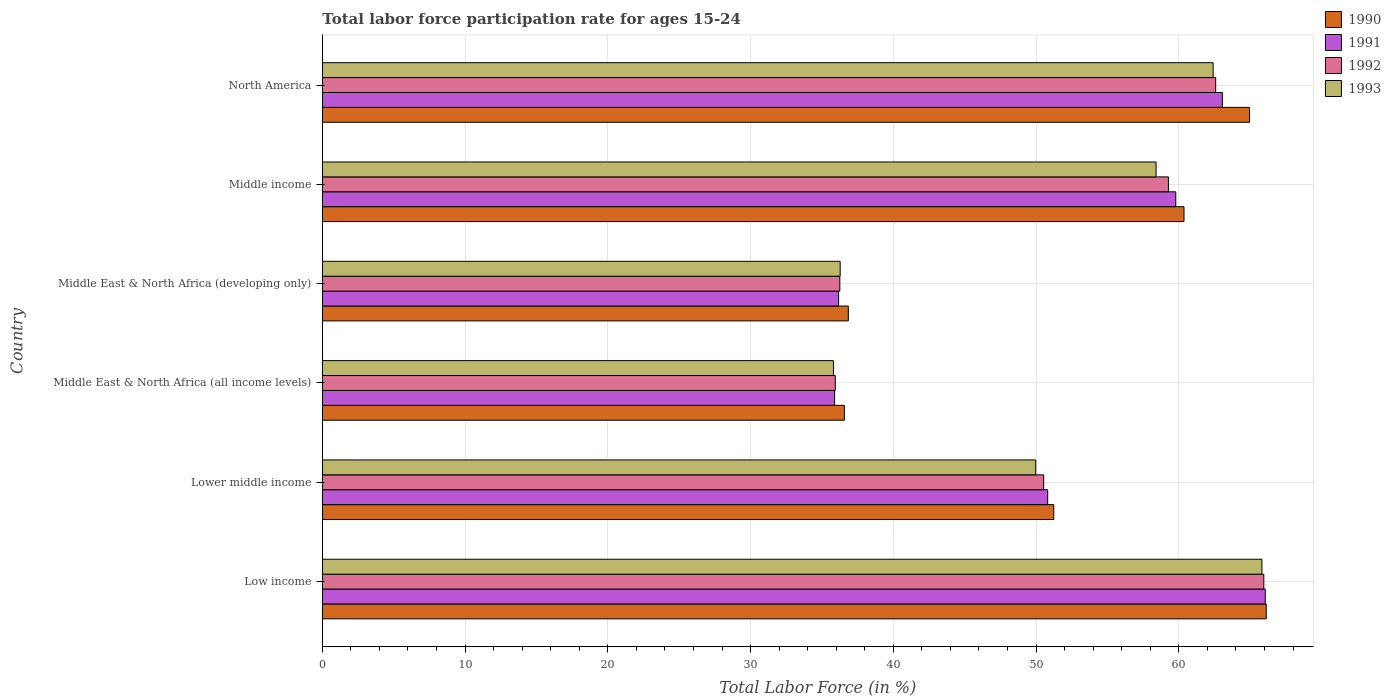How many groups of bars are there?
Provide a succinct answer. 6. Are the number of bars on each tick of the Y-axis equal?
Provide a short and direct response. Yes. What is the label of the 1st group of bars from the top?
Offer a very short reply. North America. What is the labor force participation rate in 1993 in Middle East & North Africa (developing only)?
Your answer should be compact. 36.28. Across all countries, what is the maximum labor force participation rate in 1991?
Provide a succinct answer. 66.06. Across all countries, what is the minimum labor force participation rate in 1990?
Keep it short and to the point. 36.57. In which country was the labor force participation rate in 1991 maximum?
Provide a short and direct response. Low income. In which country was the labor force participation rate in 1992 minimum?
Keep it short and to the point. Middle East & North Africa (all income levels). What is the total labor force participation rate in 1991 in the graph?
Offer a very short reply. 311.77. What is the difference between the labor force participation rate in 1993 in Low income and that in North America?
Ensure brevity in your answer.  3.42. What is the difference between the labor force participation rate in 1990 in Middle East & North Africa (all income levels) and the labor force participation rate in 1992 in Low income?
Provide a succinct answer. -29.39. What is the average labor force participation rate in 1993 per country?
Ensure brevity in your answer.  51.45. What is the difference between the labor force participation rate in 1990 and labor force participation rate in 1991 in Middle East & North Africa (all income levels)?
Your answer should be compact. 0.68. In how many countries, is the labor force participation rate in 1992 greater than 4 %?
Offer a very short reply. 6. What is the ratio of the labor force participation rate in 1990 in Low income to that in Middle East & North Africa (developing only)?
Your response must be concise. 1.79. Is the difference between the labor force participation rate in 1990 in Middle East & North Africa (developing only) and Middle income greater than the difference between the labor force participation rate in 1991 in Middle East & North Africa (developing only) and Middle income?
Your response must be concise. Yes. What is the difference between the highest and the second highest labor force participation rate in 1990?
Give a very brief answer. 1.17. What is the difference between the highest and the lowest labor force participation rate in 1992?
Make the answer very short. 30.02. Is the sum of the labor force participation rate in 1992 in Middle East & North Africa (all income levels) and North America greater than the maximum labor force participation rate in 1990 across all countries?
Keep it short and to the point. Yes. What does the 2nd bar from the top in Middle East & North Africa (developing only) represents?
Provide a succinct answer. 1992. What does the 4th bar from the bottom in Low income represents?
Give a very brief answer. 1993. What is the difference between two consecutive major ticks on the X-axis?
Provide a short and direct response. 10. What is the title of the graph?
Provide a short and direct response. Total labor force participation rate for ages 15-24. Does "2011" appear as one of the legend labels in the graph?
Make the answer very short. No. What is the Total Labor Force (in %) in 1990 in Low income?
Offer a terse response. 66.13. What is the Total Labor Force (in %) in 1991 in Low income?
Your answer should be compact. 66.06. What is the Total Labor Force (in %) in 1992 in Low income?
Ensure brevity in your answer.  65.96. What is the Total Labor Force (in %) in 1993 in Low income?
Your response must be concise. 65.82. What is the Total Labor Force (in %) of 1990 in Lower middle income?
Your answer should be very brief. 51.24. What is the Total Labor Force (in %) of 1991 in Lower middle income?
Your answer should be very brief. 50.82. What is the Total Labor Force (in %) in 1992 in Lower middle income?
Offer a very short reply. 50.54. What is the Total Labor Force (in %) of 1993 in Lower middle income?
Your answer should be compact. 49.98. What is the Total Labor Force (in %) in 1990 in Middle East & North Africa (all income levels)?
Make the answer very short. 36.57. What is the Total Labor Force (in %) of 1991 in Middle East & North Africa (all income levels)?
Ensure brevity in your answer.  35.89. What is the Total Labor Force (in %) of 1992 in Middle East & North Africa (all income levels)?
Your answer should be compact. 35.93. What is the Total Labor Force (in %) of 1993 in Middle East & North Africa (all income levels)?
Give a very brief answer. 35.81. What is the Total Labor Force (in %) in 1990 in Middle East & North Africa (developing only)?
Provide a succinct answer. 36.85. What is the Total Labor Force (in %) in 1991 in Middle East & North Africa (developing only)?
Provide a short and direct response. 36.17. What is the Total Labor Force (in %) in 1992 in Middle East & North Africa (developing only)?
Your answer should be very brief. 36.25. What is the Total Labor Force (in %) in 1993 in Middle East & North Africa (developing only)?
Ensure brevity in your answer.  36.28. What is the Total Labor Force (in %) in 1990 in Middle income?
Give a very brief answer. 60.36. What is the Total Labor Force (in %) in 1991 in Middle income?
Offer a terse response. 59.79. What is the Total Labor Force (in %) in 1992 in Middle income?
Give a very brief answer. 59.27. What is the Total Labor Force (in %) of 1993 in Middle income?
Provide a succinct answer. 58.41. What is the Total Labor Force (in %) of 1990 in North America?
Your answer should be compact. 64.95. What is the Total Labor Force (in %) of 1991 in North America?
Your response must be concise. 63.05. What is the Total Labor Force (in %) of 1992 in North America?
Provide a succinct answer. 62.58. What is the Total Labor Force (in %) of 1993 in North America?
Offer a terse response. 62.41. Across all countries, what is the maximum Total Labor Force (in %) of 1990?
Provide a succinct answer. 66.13. Across all countries, what is the maximum Total Labor Force (in %) of 1991?
Offer a terse response. 66.06. Across all countries, what is the maximum Total Labor Force (in %) in 1992?
Offer a very short reply. 65.96. Across all countries, what is the maximum Total Labor Force (in %) of 1993?
Ensure brevity in your answer.  65.82. Across all countries, what is the minimum Total Labor Force (in %) in 1990?
Provide a short and direct response. 36.57. Across all countries, what is the minimum Total Labor Force (in %) in 1991?
Your answer should be compact. 35.89. Across all countries, what is the minimum Total Labor Force (in %) of 1992?
Offer a terse response. 35.93. Across all countries, what is the minimum Total Labor Force (in %) of 1993?
Provide a succinct answer. 35.81. What is the total Total Labor Force (in %) of 1990 in the graph?
Give a very brief answer. 316.1. What is the total Total Labor Force (in %) in 1991 in the graph?
Give a very brief answer. 311.77. What is the total Total Labor Force (in %) of 1992 in the graph?
Your answer should be compact. 310.54. What is the total Total Labor Force (in %) in 1993 in the graph?
Offer a very short reply. 308.7. What is the difference between the Total Labor Force (in %) in 1990 in Low income and that in Lower middle income?
Your response must be concise. 14.88. What is the difference between the Total Labor Force (in %) of 1991 in Low income and that in Lower middle income?
Give a very brief answer. 15.24. What is the difference between the Total Labor Force (in %) in 1992 in Low income and that in Lower middle income?
Make the answer very short. 15.42. What is the difference between the Total Labor Force (in %) of 1993 in Low income and that in Lower middle income?
Keep it short and to the point. 15.85. What is the difference between the Total Labor Force (in %) in 1990 in Low income and that in Middle East & North Africa (all income levels)?
Your response must be concise. 29.55. What is the difference between the Total Labor Force (in %) of 1991 in Low income and that in Middle East & North Africa (all income levels)?
Offer a terse response. 30.17. What is the difference between the Total Labor Force (in %) in 1992 in Low income and that in Middle East & North Africa (all income levels)?
Keep it short and to the point. 30.02. What is the difference between the Total Labor Force (in %) of 1993 in Low income and that in Middle East & North Africa (all income levels)?
Your response must be concise. 30.02. What is the difference between the Total Labor Force (in %) in 1990 in Low income and that in Middle East & North Africa (developing only)?
Provide a succinct answer. 29.28. What is the difference between the Total Labor Force (in %) of 1991 in Low income and that in Middle East & North Africa (developing only)?
Provide a short and direct response. 29.89. What is the difference between the Total Labor Force (in %) in 1992 in Low income and that in Middle East & North Africa (developing only)?
Offer a terse response. 29.7. What is the difference between the Total Labor Force (in %) of 1993 in Low income and that in Middle East & North Africa (developing only)?
Give a very brief answer. 29.55. What is the difference between the Total Labor Force (in %) of 1990 in Low income and that in Middle income?
Ensure brevity in your answer.  5.76. What is the difference between the Total Labor Force (in %) of 1991 in Low income and that in Middle income?
Your answer should be compact. 6.27. What is the difference between the Total Labor Force (in %) of 1992 in Low income and that in Middle income?
Provide a short and direct response. 6.68. What is the difference between the Total Labor Force (in %) of 1993 in Low income and that in Middle income?
Offer a very short reply. 7.41. What is the difference between the Total Labor Force (in %) of 1990 in Low income and that in North America?
Your answer should be compact. 1.17. What is the difference between the Total Labor Force (in %) in 1991 in Low income and that in North America?
Ensure brevity in your answer.  3. What is the difference between the Total Labor Force (in %) in 1992 in Low income and that in North America?
Provide a short and direct response. 3.37. What is the difference between the Total Labor Force (in %) in 1993 in Low income and that in North America?
Provide a short and direct response. 3.42. What is the difference between the Total Labor Force (in %) in 1990 in Lower middle income and that in Middle East & North Africa (all income levels)?
Provide a succinct answer. 14.67. What is the difference between the Total Labor Force (in %) in 1991 in Lower middle income and that in Middle East & North Africa (all income levels)?
Your answer should be very brief. 14.93. What is the difference between the Total Labor Force (in %) in 1992 in Lower middle income and that in Middle East & North Africa (all income levels)?
Provide a succinct answer. 14.6. What is the difference between the Total Labor Force (in %) in 1993 in Lower middle income and that in Middle East & North Africa (all income levels)?
Provide a short and direct response. 14.17. What is the difference between the Total Labor Force (in %) in 1990 in Lower middle income and that in Middle East & North Africa (developing only)?
Offer a terse response. 14.39. What is the difference between the Total Labor Force (in %) of 1991 in Lower middle income and that in Middle East & North Africa (developing only)?
Offer a terse response. 14.65. What is the difference between the Total Labor Force (in %) of 1992 in Lower middle income and that in Middle East & North Africa (developing only)?
Provide a short and direct response. 14.28. What is the difference between the Total Labor Force (in %) in 1993 in Lower middle income and that in Middle East & North Africa (developing only)?
Your answer should be very brief. 13.7. What is the difference between the Total Labor Force (in %) of 1990 in Lower middle income and that in Middle income?
Ensure brevity in your answer.  -9.12. What is the difference between the Total Labor Force (in %) in 1991 in Lower middle income and that in Middle income?
Ensure brevity in your answer.  -8.97. What is the difference between the Total Labor Force (in %) of 1992 in Lower middle income and that in Middle income?
Ensure brevity in your answer.  -8.74. What is the difference between the Total Labor Force (in %) in 1993 in Lower middle income and that in Middle income?
Provide a succinct answer. -8.43. What is the difference between the Total Labor Force (in %) of 1990 in Lower middle income and that in North America?
Your answer should be very brief. -13.71. What is the difference between the Total Labor Force (in %) in 1991 in Lower middle income and that in North America?
Your response must be concise. -12.24. What is the difference between the Total Labor Force (in %) in 1992 in Lower middle income and that in North America?
Give a very brief answer. -12.05. What is the difference between the Total Labor Force (in %) of 1993 in Lower middle income and that in North America?
Your answer should be very brief. -12.43. What is the difference between the Total Labor Force (in %) in 1990 in Middle East & North Africa (all income levels) and that in Middle East & North Africa (developing only)?
Give a very brief answer. -0.28. What is the difference between the Total Labor Force (in %) in 1991 in Middle East & North Africa (all income levels) and that in Middle East & North Africa (developing only)?
Offer a very short reply. -0.28. What is the difference between the Total Labor Force (in %) in 1992 in Middle East & North Africa (all income levels) and that in Middle East & North Africa (developing only)?
Provide a succinct answer. -0.32. What is the difference between the Total Labor Force (in %) in 1993 in Middle East & North Africa (all income levels) and that in Middle East & North Africa (developing only)?
Provide a short and direct response. -0.47. What is the difference between the Total Labor Force (in %) of 1990 in Middle East & North Africa (all income levels) and that in Middle income?
Keep it short and to the point. -23.79. What is the difference between the Total Labor Force (in %) in 1991 in Middle East & North Africa (all income levels) and that in Middle income?
Ensure brevity in your answer.  -23.9. What is the difference between the Total Labor Force (in %) of 1992 in Middle East & North Africa (all income levels) and that in Middle income?
Offer a very short reply. -23.34. What is the difference between the Total Labor Force (in %) in 1993 in Middle East & North Africa (all income levels) and that in Middle income?
Offer a very short reply. -22.6. What is the difference between the Total Labor Force (in %) in 1990 in Middle East & North Africa (all income levels) and that in North America?
Offer a very short reply. -28.38. What is the difference between the Total Labor Force (in %) of 1991 in Middle East & North Africa (all income levels) and that in North America?
Give a very brief answer. -27.16. What is the difference between the Total Labor Force (in %) in 1992 in Middle East & North Africa (all income levels) and that in North America?
Provide a succinct answer. -26.65. What is the difference between the Total Labor Force (in %) in 1993 in Middle East & North Africa (all income levels) and that in North America?
Provide a short and direct response. -26.6. What is the difference between the Total Labor Force (in %) in 1990 in Middle East & North Africa (developing only) and that in Middle income?
Your response must be concise. -23.52. What is the difference between the Total Labor Force (in %) of 1991 in Middle East & North Africa (developing only) and that in Middle income?
Ensure brevity in your answer.  -23.62. What is the difference between the Total Labor Force (in %) in 1992 in Middle East & North Africa (developing only) and that in Middle income?
Keep it short and to the point. -23.02. What is the difference between the Total Labor Force (in %) in 1993 in Middle East & North Africa (developing only) and that in Middle income?
Your answer should be compact. -22.13. What is the difference between the Total Labor Force (in %) in 1990 in Middle East & North Africa (developing only) and that in North America?
Your answer should be very brief. -28.11. What is the difference between the Total Labor Force (in %) of 1991 in Middle East & North Africa (developing only) and that in North America?
Offer a very short reply. -26.88. What is the difference between the Total Labor Force (in %) of 1992 in Middle East & North Africa (developing only) and that in North America?
Offer a terse response. -26.33. What is the difference between the Total Labor Force (in %) in 1993 in Middle East & North Africa (developing only) and that in North America?
Provide a short and direct response. -26.13. What is the difference between the Total Labor Force (in %) in 1990 in Middle income and that in North America?
Your answer should be compact. -4.59. What is the difference between the Total Labor Force (in %) in 1991 in Middle income and that in North America?
Make the answer very short. -3.26. What is the difference between the Total Labor Force (in %) of 1992 in Middle income and that in North America?
Your response must be concise. -3.31. What is the difference between the Total Labor Force (in %) of 1993 in Middle income and that in North America?
Make the answer very short. -4. What is the difference between the Total Labor Force (in %) of 1990 in Low income and the Total Labor Force (in %) of 1991 in Lower middle income?
Make the answer very short. 15.31. What is the difference between the Total Labor Force (in %) in 1990 in Low income and the Total Labor Force (in %) in 1992 in Lower middle income?
Provide a succinct answer. 15.59. What is the difference between the Total Labor Force (in %) in 1990 in Low income and the Total Labor Force (in %) in 1993 in Lower middle income?
Your response must be concise. 16.15. What is the difference between the Total Labor Force (in %) of 1991 in Low income and the Total Labor Force (in %) of 1992 in Lower middle income?
Give a very brief answer. 15.52. What is the difference between the Total Labor Force (in %) in 1991 in Low income and the Total Labor Force (in %) in 1993 in Lower middle income?
Your answer should be compact. 16.08. What is the difference between the Total Labor Force (in %) in 1992 in Low income and the Total Labor Force (in %) in 1993 in Lower middle income?
Ensure brevity in your answer.  15.98. What is the difference between the Total Labor Force (in %) of 1990 in Low income and the Total Labor Force (in %) of 1991 in Middle East & North Africa (all income levels)?
Make the answer very short. 30.24. What is the difference between the Total Labor Force (in %) of 1990 in Low income and the Total Labor Force (in %) of 1992 in Middle East & North Africa (all income levels)?
Provide a short and direct response. 30.19. What is the difference between the Total Labor Force (in %) of 1990 in Low income and the Total Labor Force (in %) of 1993 in Middle East & North Africa (all income levels)?
Your answer should be compact. 30.32. What is the difference between the Total Labor Force (in %) of 1991 in Low income and the Total Labor Force (in %) of 1992 in Middle East & North Africa (all income levels)?
Offer a very short reply. 30.12. What is the difference between the Total Labor Force (in %) of 1991 in Low income and the Total Labor Force (in %) of 1993 in Middle East & North Africa (all income levels)?
Your response must be concise. 30.25. What is the difference between the Total Labor Force (in %) of 1992 in Low income and the Total Labor Force (in %) of 1993 in Middle East & North Africa (all income levels)?
Your response must be concise. 30.15. What is the difference between the Total Labor Force (in %) of 1990 in Low income and the Total Labor Force (in %) of 1991 in Middle East & North Africa (developing only)?
Provide a succinct answer. 29.96. What is the difference between the Total Labor Force (in %) of 1990 in Low income and the Total Labor Force (in %) of 1992 in Middle East & North Africa (developing only)?
Your response must be concise. 29.87. What is the difference between the Total Labor Force (in %) in 1990 in Low income and the Total Labor Force (in %) in 1993 in Middle East & North Africa (developing only)?
Offer a terse response. 29.85. What is the difference between the Total Labor Force (in %) of 1991 in Low income and the Total Labor Force (in %) of 1992 in Middle East & North Africa (developing only)?
Provide a short and direct response. 29.8. What is the difference between the Total Labor Force (in %) in 1991 in Low income and the Total Labor Force (in %) in 1993 in Middle East & North Africa (developing only)?
Provide a short and direct response. 29.78. What is the difference between the Total Labor Force (in %) of 1992 in Low income and the Total Labor Force (in %) of 1993 in Middle East & North Africa (developing only)?
Provide a succinct answer. 29.68. What is the difference between the Total Labor Force (in %) in 1990 in Low income and the Total Labor Force (in %) in 1991 in Middle income?
Keep it short and to the point. 6.34. What is the difference between the Total Labor Force (in %) of 1990 in Low income and the Total Labor Force (in %) of 1992 in Middle income?
Ensure brevity in your answer.  6.85. What is the difference between the Total Labor Force (in %) of 1990 in Low income and the Total Labor Force (in %) of 1993 in Middle income?
Your response must be concise. 7.72. What is the difference between the Total Labor Force (in %) of 1991 in Low income and the Total Labor Force (in %) of 1992 in Middle income?
Provide a succinct answer. 6.78. What is the difference between the Total Labor Force (in %) of 1991 in Low income and the Total Labor Force (in %) of 1993 in Middle income?
Keep it short and to the point. 7.65. What is the difference between the Total Labor Force (in %) in 1992 in Low income and the Total Labor Force (in %) in 1993 in Middle income?
Your answer should be compact. 7.55. What is the difference between the Total Labor Force (in %) of 1990 in Low income and the Total Labor Force (in %) of 1991 in North America?
Keep it short and to the point. 3.07. What is the difference between the Total Labor Force (in %) of 1990 in Low income and the Total Labor Force (in %) of 1992 in North America?
Your answer should be compact. 3.54. What is the difference between the Total Labor Force (in %) in 1990 in Low income and the Total Labor Force (in %) in 1993 in North America?
Keep it short and to the point. 3.72. What is the difference between the Total Labor Force (in %) of 1991 in Low income and the Total Labor Force (in %) of 1992 in North America?
Make the answer very short. 3.47. What is the difference between the Total Labor Force (in %) of 1991 in Low income and the Total Labor Force (in %) of 1993 in North America?
Give a very brief answer. 3.65. What is the difference between the Total Labor Force (in %) of 1992 in Low income and the Total Labor Force (in %) of 1993 in North America?
Give a very brief answer. 3.55. What is the difference between the Total Labor Force (in %) in 1990 in Lower middle income and the Total Labor Force (in %) in 1991 in Middle East & North Africa (all income levels)?
Give a very brief answer. 15.35. What is the difference between the Total Labor Force (in %) in 1990 in Lower middle income and the Total Labor Force (in %) in 1992 in Middle East & North Africa (all income levels)?
Make the answer very short. 15.31. What is the difference between the Total Labor Force (in %) of 1990 in Lower middle income and the Total Labor Force (in %) of 1993 in Middle East & North Africa (all income levels)?
Keep it short and to the point. 15.44. What is the difference between the Total Labor Force (in %) in 1991 in Lower middle income and the Total Labor Force (in %) in 1992 in Middle East & North Africa (all income levels)?
Your response must be concise. 14.88. What is the difference between the Total Labor Force (in %) in 1991 in Lower middle income and the Total Labor Force (in %) in 1993 in Middle East & North Africa (all income levels)?
Your answer should be compact. 15.01. What is the difference between the Total Labor Force (in %) in 1992 in Lower middle income and the Total Labor Force (in %) in 1993 in Middle East & North Africa (all income levels)?
Offer a very short reply. 14.73. What is the difference between the Total Labor Force (in %) of 1990 in Lower middle income and the Total Labor Force (in %) of 1991 in Middle East & North Africa (developing only)?
Provide a short and direct response. 15.07. What is the difference between the Total Labor Force (in %) in 1990 in Lower middle income and the Total Labor Force (in %) in 1992 in Middle East & North Africa (developing only)?
Your answer should be very brief. 14.99. What is the difference between the Total Labor Force (in %) of 1990 in Lower middle income and the Total Labor Force (in %) of 1993 in Middle East & North Africa (developing only)?
Your response must be concise. 14.96. What is the difference between the Total Labor Force (in %) of 1991 in Lower middle income and the Total Labor Force (in %) of 1992 in Middle East & North Africa (developing only)?
Your response must be concise. 14.56. What is the difference between the Total Labor Force (in %) of 1991 in Lower middle income and the Total Labor Force (in %) of 1993 in Middle East & North Africa (developing only)?
Provide a short and direct response. 14.54. What is the difference between the Total Labor Force (in %) of 1992 in Lower middle income and the Total Labor Force (in %) of 1993 in Middle East & North Africa (developing only)?
Your answer should be compact. 14.26. What is the difference between the Total Labor Force (in %) of 1990 in Lower middle income and the Total Labor Force (in %) of 1991 in Middle income?
Provide a succinct answer. -8.55. What is the difference between the Total Labor Force (in %) in 1990 in Lower middle income and the Total Labor Force (in %) in 1992 in Middle income?
Offer a very short reply. -8.03. What is the difference between the Total Labor Force (in %) in 1990 in Lower middle income and the Total Labor Force (in %) in 1993 in Middle income?
Your response must be concise. -7.17. What is the difference between the Total Labor Force (in %) of 1991 in Lower middle income and the Total Labor Force (in %) of 1992 in Middle income?
Ensure brevity in your answer.  -8.46. What is the difference between the Total Labor Force (in %) of 1991 in Lower middle income and the Total Labor Force (in %) of 1993 in Middle income?
Your answer should be very brief. -7.59. What is the difference between the Total Labor Force (in %) of 1992 in Lower middle income and the Total Labor Force (in %) of 1993 in Middle income?
Give a very brief answer. -7.87. What is the difference between the Total Labor Force (in %) in 1990 in Lower middle income and the Total Labor Force (in %) in 1991 in North America?
Provide a short and direct response. -11.81. What is the difference between the Total Labor Force (in %) in 1990 in Lower middle income and the Total Labor Force (in %) in 1992 in North America?
Make the answer very short. -11.34. What is the difference between the Total Labor Force (in %) of 1990 in Lower middle income and the Total Labor Force (in %) of 1993 in North America?
Ensure brevity in your answer.  -11.16. What is the difference between the Total Labor Force (in %) in 1991 in Lower middle income and the Total Labor Force (in %) in 1992 in North America?
Give a very brief answer. -11.77. What is the difference between the Total Labor Force (in %) of 1991 in Lower middle income and the Total Labor Force (in %) of 1993 in North America?
Give a very brief answer. -11.59. What is the difference between the Total Labor Force (in %) in 1992 in Lower middle income and the Total Labor Force (in %) in 1993 in North America?
Your response must be concise. -11.87. What is the difference between the Total Labor Force (in %) in 1990 in Middle East & North Africa (all income levels) and the Total Labor Force (in %) in 1991 in Middle East & North Africa (developing only)?
Ensure brevity in your answer.  0.4. What is the difference between the Total Labor Force (in %) of 1990 in Middle East & North Africa (all income levels) and the Total Labor Force (in %) of 1992 in Middle East & North Africa (developing only)?
Your answer should be compact. 0.32. What is the difference between the Total Labor Force (in %) of 1990 in Middle East & North Africa (all income levels) and the Total Labor Force (in %) of 1993 in Middle East & North Africa (developing only)?
Provide a succinct answer. 0.29. What is the difference between the Total Labor Force (in %) of 1991 in Middle East & North Africa (all income levels) and the Total Labor Force (in %) of 1992 in Middle East & North Africa (developing only)?
Offer a terse response. -0.36. What is the difference between the Total Labor Force (in %) in 1991 in Middle East & North Africa (all income levels) and the Total Labor Force (in %) in 1993 in Middle East & North Africa (developing only)?
Ensure brevity in your answer.  -0.39. What is the difference between the Total Labor Force (in %) of 1992 in Middle East & North Africa (all income levels) and the Total Labor Force (in %) of 1993 in Middle East & North Africa (developing only)?
Keep it short and to the point. -0.34. What is the difference between the Total Labor Force (in %) in 1990 in Middle East & North Africa (all income levels) and the Total Labor Force (in %) in 1991 in Middle income?
Provide a short and direct response. -23.22. What is the difference between the Total Labor Force (in %) of 1990 in Middle East & North Africa (all income levels) and the Total Labor Force (in %) of 1992 in Middle income?
Give a very brief answer. -22.7. What is the difference between the Total Labor Force (in %) in 1990 in Middle East & North Africa (all income levels) and the Total Labor Force (in %) in 1993 in Middle income?
Ensure brevity in your answer.  -21.84. What is the difference between the Total Labor Force (in %) of 1991 in Middle East & North Africa (all income levels) and the Total Labor Force (in %) of 1992 in Middle income?
Ensure brevity in your answer.  -23.39. What is the difference between the Total Labor Force (in %) in 1991 in Middle East & North Africa (all income levels) and the Total Labor Force (in %) in 1993 in Middle income?
Give a very brief answer. -22.52. What is the difference between the Total Labor Force (in %) of 1992 in Middle East & North Africa (all income levels) and the Total Labor Force (in %) of 1993 in Middle income?
Provide a short and direct response. -22.47. What is the difference between the Total Labor Force (in %) in 1990 in Middle East & North Africa (all income levels) and the Total Labor Force (in %) in 1991 in North America?
Keep it short and to the point. -26.48. What is the difference between the Total Labor Force (in %) in 1990 in Middle East & North Africa (all income levels) and the Total Labor Force (in %) in 1992 in North America?
Ensure brevity in your answer.  -26.01. What is the difference between the Total Labor Force (in %) of 1990 in Middle East & North Africa (all income levels) and the Total Labor Force (in %) of 1993 in North America?
Your response must be concise. -25.84. What is the difference between the Total Labor Force (in %) of 1991 in Middle East & North Africa (all income levels) and the Total Labor Force (in %) of 1992 in North America?
Your response must be concise. -26.69. What is the difference between the Total Labor Force (in %) in 1991 in Middle East & North Africa (all income levels) and the Total Labor Force (in %) in 1993 in North America?
Give a very brief answer. -26.52. What is the difference between the Total Labor Force (in %) of 1992 in Middle East & North Africa (all income levels) and the Total Labor Force (in %) of 1993 in North America?
Offer a very short reply. -26.47. What is the difference between the Total Labor Force (in %) of 1990 in Middle East & North Africa (developing only) and the Total Labor Force (in %) of 1991 in Middle income?
Offer a terse response. -22.94. What is the difference between the Total Labor Force (in %) of 1990 in Middle East & North Africa (developing only) and the Total Labor Force (in %) of 1992 in Middle income?
Offer a very short reply. -22.43. What is the difference between the Total Labor Force (in %) of 1990 in Middle East & North Africa (developing only) and the Total Labor Force (in %) of 1993 in Middle income?
Make the answer very short. -21.56. What is the difference between the Total Labor Force (in %) of 1991 in Middle East & North Africa (developing only) and the Total Labor Force (in %) of 1992 in Middle income?
Ensure brevity in your answer.  -23.11. What is the difference between the Total Labor Force (in %) in 1991 in Middle East & North Africa (developing only) and the Total Labor Force (in %) in 1993 in Middle income?
Provide a succinct answer. -22.24. What is the difference between the Total Labor Force (in %) in 1992 in Middle East & North Africa (developing only) and the Total Labor Force (in %) in 1993 in Middle income?
Give a very brief answer. -22.16. What is the difference between the Total Labor Force (in %) of 1990 in Middle East & North Africa (developing only) and the Total Labor Force (in %) of 1991 in North America?
Give a very brief answer. -26.2. What is the difference between the Total Labor Force (in %) of 1990 in Middle East & North Africa (developing only) and the Total Labor Force (in %) of 1992 in North America?
Your answer should be compact. -25.74. What is the difference between the Total Labor Force (in %) in 1990 in Middle East & North Africa (developing only) and the Total Labor Force (in %) in 1993 in North America?
Offer a very short reply. -25.56. What is the difference between the Total Labor Force (in %) in 1991 in Middle East & North Africa (developing only) and the Total Labor Force (in %) in 1992 in North America?
Provide a succinct answer. -26.42. What is the difference between the Total Labor Force (in %) of 1991 in Middle East & North Africa (developing only) and the Total Labor Force (in %) of 1993 in North America?
Your response must be concise. -26.24. What is the difference between the Total Labor Force (in %) of 1992 in Middle East & North Africa (developing only) and the Total Labor Force (in %) of 1993 in North America?
Your answer should be compact. -26.15. What is the difference between the Total Labor Force (in %) in 1990 in Middle income and the Total Labor Force (in %) in 1991 in North America?
Your response must be concise. -2.69. What is the difference between the Total Labor Force (in %) in 1990 in Middle income and the Total Labor Force (in %) in 1992 in North America?
Ensure brevity in your answer.  -2.22. What is the difference between the Total Labor Force (in %) in 1990 in Middle income and the Total Labor Force (in %) in 1993 in North America?
Provide a succinct answer. -2.04. What is the difference between the Total Labor Force (in %) in 1991 in Middle income and the Total Labor Force (in %) in 1992 in North America?
Give a very brief answer. -2.8. What is the difference between the Total Labor Force (in %) of 1991 in Middle income and the Total Labor Force (in %) of 1993 in North America?
Your answer should be compact. -2.62. What is the difference between the Total Labor Force (in %) of 1992 in Middle income and the Total Labor Force (in %) of 1993 in North America?
Provide a short and direct response. -3.13. What is the average Total Labor Force (in %) in 1990 per country?
Your response must be concise. 52.68. What is the average Total Labor Force (in %) of 1991 per country?
Give a very brief answer. 51.96. What is the average Total Labor Force (in %) of 1992 per country?
Provide a succinct answer. 51.76. What is the average Total Labor Force (in %) in 1993 per country?
Offer a terse response. 51.45. What is the difference between the Total Labor Force (in %) in 1990 and Total Labor Force (in %) in 1991 in Low income?
Provide a succinct answer. 0.07. What is the difference between the Total Labor Force (in %) of 1990 and Total Labor Force (in %) of 1992 in Low income?
Ensure brevity in your answer.  0.17. What is the difference between the Total Labor Force (in %) of 1990 and Total Labor Force (in %) of 1993 in Low income?
Make the answer very short. 0.3. What is the difference between the Total Labor Force (in %) in 1991 and Total Labor Force (in %) in 1992 in Low income?
Your response must be concise. 0.1. What is the difference between the Total Labor Force (in %) in 1991 and Total Labor Force (in %) in 1993 in Low income?
Give a very brief answer. 0.23. What is the difference between the Total Labor Force (in %) of 1992 and Total Labor Force (in %) of 1993 in Low income?
Keep it short and to the point. 0.13. What is the difference between the Total Labor Force (in %) of 1990 and Total Labor Force (in %) of 1991 in Lower middle income?
Make the answer very short. 0.43. What is the difference between the Total Labor Force (in %) in 1990 and Total Labor Force (in %) in 1992 in Lower middle income?
Keep it short and to the point. 0.71. What is the difference between the Total Labor Force (in %) of 1990 and Total Labor Force (in %) of 1993 in Lower middle income?
Make the answer very short. 1.27. What is the difference between the Total Labor Force (in %) in 1991 and Total Labor Force (in %) in 1992 in Lower middle income?
Keep it short and to the point. 0.28. What is the difference between the Total Labor Force (in %) in 1991 and Total Labor Force (in %) in 1993 in Lower middle income?
Offer a terse response. 0.84. What is the difference between the Total Labor Force (in %) in 1992 and Total Labor Force (in %) in 1993 in Lower middle income?
Your answer should be very brief. 0.56. What is the difference between the Total Labor Force (in %) in 1990 and Total Labor Force (in %) in 1991 in Middle East & North Africa (all income levels)?
Give a very brief answer. 0.68. What is the difference between the Total Labor Force (in %) of 1990 and Total Labor Force (in %) of 1992 in Middle East & North Africa (all income levels)?
Give a very brief answer. 0.64. What is the difference between the Total Labor Force (in %) of 1990 and Total Labor Force (in %) of 1993 in Middle East & North Africa (all income levels)?
Give a very brief answer. 0.76. What is the difference between the Total Labor Force (in %) of 1991 and Total Labor Force (in %) of 1992 in Middle East & North Africa (all income levels)?
Make the answer very short. -0.05. What is the difference between the Total Labor Force (in %) of 1991 and Total Labor Force (in %) of 1993 in Middle East & North Africa (all income levels)?
Ensure brevity in your answer.  0.08. What is the difference between the Total Labor Force (in %) in 1992 and Total Labor Force (in %) in 1993 in Middle East & North Africa (all income levels)?
Your answer should be very brief. 0.13. What is the difference between the Total Labor Force (in %) in 1990 and Total Labor Force (in %) in 1991 in Middle East & North Africa (developing only)?
Your answer should be compact. 0.68. What is the difference between the Total Labor Force (in %) of 1990 and Total Labor Force (in %) of 1992 in Middle East & North Africa (developing only)?
Your answer should be very brief. 0.6. What is the difference between the Total Labor Force (in %) in 1990 and Total Labor Force (in %) in 1993 in Middle East & North Africa (developing only)?
Give a very brief answer. 0.57. What is the difference between the Total Labor Force (in %) of 1991 and Total Labor Force (in %) of 1992 in Middle East & North Africa (developing only)?
Make the answer very short. -0.08. What is the difference between the Total Labor Force (in %) in 1991 and Total Labor Force (in %) in 1993 in Middle East & North Africa (developing only)?
Offer a terse response. -0.11. What is the difference between the Total Labor Force (in %) in 1992 and Total Labor Force (in %) in 1993 in Middle East & North Africa (developing only)?
Your answer should be very brief. -0.02. What is the difference between the Total Labor Force (in %) of 1990 and Total Labor Force (in %) of 1991 in Middle income?
Make the answer very short. 0.58. What is the difference between the Total Labor Force (in %) of 1990 and Total Labor Force (in %) of 1992 in Middle income?
Provide a short and direct response. 1.09. What is the difference between the Total Labor Force (in %) of 1990 and Total Labor Force (in %) of 1993 in Middle income?
Your answer should be compact. 1.96. What is the difference between the Total Labor Force (in %) in 1991 and Total Labor Force (in %) in 1992 in Middle income?
Ensure brevity in your answer.  0.51. What is the difference between the Total Labor Force (in %) in 1991 and Total Labor Force (in %) in 1993 in Middle income?
Provide a succinct answer. 1.38. What is the difference between the Total Labor Force (in %) of 1992 and Total Labor Force (in %) of 1993 in Middle income?
Your response must be concise. 0.87. What is the difference between the Total Labor Force (in %) of 1990 and Total Labor Force (in %) of 1991 in North America?
Provide a succinct answer. 1.9. What is the difference between the Total Labor Force (in %) of 1990 and Total Labor Force (in %) of 1992 in North America?
Provide a short and direct response. 2.37. What is the difference between the Total Labor Force (in %) in 1990 and Total Labor Force (in %) in 1993 in North America?
Provide a succinct answer. 2.55. What is the difference between the Total Labor Force (in %) in 1991 and Total Labor Force (in %) in 1992 in North America?
Provide a short and direct response. 0.47. What is the difference between the Total Labor Force (in %) in 1991 and Total Labor Force (in %) in 1993 in North America?
Provide a succinct answer. 0.65. What is the difference between the Total Labor Force (in %) in 1992 and Total Labor Force (in %) in 1993 in North America?
Ensure brevity in your answer.  0.18. What is the ratio of the Total Labor Force (in %) of 1990 in Low income to that in Lower middle income?
Make the answer very short. 1.29. What is the ratio of the Total Labor Force (in %) of 1991 in Low income to that in Lower middle income?
Offer a terse response. 1.3. What is the ratio of the Total Labor Force (in %) in 1992 in Low income to that in Lower middle income?
Your response must be concise. 1.31. What is the ratio of the Total Labor Force (in %) in 1993 in Low income to that in Lower middle income?
Your answer should be compact. 1.32. What is the ratio of the Total Labor Force (in %) of 1990 in Low income to that in Middle East & North Africa (all income levels)?
Offer a terse response. 1.81. What is the ratio of the Total Labor Force (in %) of 1991 in Low income to that in Middle East & North Africa (all income levels)?
Provide a succinct answer. 1.84. What is the ratio of the Total Labor Force (in %) in 1992 in Low income to that in Middle East & North Africa (all income levels)?
Your response must be concise. 1.84. What is the ratio of the Total Labor Force (in %) of 1993 in Low income to that in Middle East & North Africa (all income levels)?
Give a very brief answer. 1.84. What is the ratio of the Total Labor Force (in %) of 1990 in Low income to that in Middle East & North Africa (developing only)?
Give a very brief answer. 1.79. What is the ratio of the Total Labor Force (in %) of 1991 in Low income to that in Middle East & North Africa (developing only)?
Offer a very short reply. 1.83. What is the ratio of the Total Labor Force (in %) of 1992 in Low income to that in Middle East & North Africa (developing only)?
Provide a succinct answer. 1.82. What is the ratio of the Total Labor Force (in %) of 1993 in Low income to that in Middle East & North Africa (developing only)?
Make the answer very short. 1.81. What is the ratio of the Total Labor Force (in %) of 1990 in Low income to that in Middle income?
Provide a succinct answer. 1.1. What is the ratio of the Total Labor Force (in %) of 1991 in Low income to that in Middle income?
Offer a very short reply. 1.1. What is the ratio of the Total Labor Force (in %) in 1992 in Low income to that in Middle income?
Ensure brevity in your answer.  1.11. What is the ratio of the Total Labor Force (in %) in 1993 in Low income to that in Middle income?
Your answer should be compact. 1.13. What is the ratio of the Total Labor Force (in %) of 1990 in Low income to that in North America?
Your response must be concise. 1.02. What is the ratio of the Total Labor Force (in %) in 1991 in Low income to that in North America?
Offer a terse response. 1.05. What is the ratio of the Total Labor Force (in %) of 1992 in Low income to that in North America?
Your response must be concise. 1.05. What is the ratio of the Total Labor Force (in %) of 1993 in Low income to that in North America?
Offer a very short reply. 1.05. What is the ratio of the Total Labor Force (in %) in 1990 in Lower middle income to that in Middle East & North Africa (all income levels)?
Ensure brevity in your answer.  1.4. What is the ratio of the Total Labor Force (in %) in 1991 in Lower middle income to that in Middle East & North Africa (all income levels)?
Ensure brevity in your answer.  1.42. What is the ratio of the Total Labor Force (in %) of 1992 in Lower middle income to that in Middle East & North Africa (all income levels)?
Your response must be concise. 1.41. What is the ratio of the Total Labor Force (in %) in 1993 in Lower middle income to that in Middle East & North Africa (all income levels)?
Make the answer very short. 1.4. What is the ratio of the Total Labor Force (in %) in 1990 in Lower middle income to that in Middle East & North Africa (developing only)?
Give a very brief answer. 1.39. What is the ratio of the Total Labor Force (in %) of 1991 in Lower middle income to that in Middle East & North Africa (developing only)?
Ensure brevity in your answer.  1.41. What is the ratio of the Total Labor Force (in %) of 1992 in Lower middle income to that in Middle East & North Africa (developing only)?
Provide a succinct answer. 1.39. What is the ratio of the Total Labor Force (in %) of 1993 in Lower middle income to that in Middle East & North Africa (developing only)?
Make the answer very short. 1.38. What is the ratio of the Total Labor Force (in %) in 1990 in Lower middle income to that in Middle income?
Provide a short and direct response. 0.85. What is the ratio of the Total Labor Force (in %) of 1991 in Lower middle income to that in Middle income?
Give a very brief answer. 0.85. What is the ratio of the Total Labor Force (in %) in 1992 in Lower middle income to that in Middle income?
Provide a short and direct response. 0.85. What is the ratio of the Total Labor Force (in %) of 1993 in Lower middle income to that in Middle income?
Provide a succinct answer. 0.86. What is the ratio of the Total Labor Force (in %) of 1990 in Lower middle income to that in North America?
Ensure brevity in your answer.  0.79. What is the ratio of the Total Labor Force (in %) in 1991 in Lower middle income to that in North America?
Your answer should be compact. 0.81. What is the ratio of the Total Labor Force (in %) of 1992 in Lower middle income to that in North America?
Provide a succinct answer. 0.81. What is the ratio of the Total Labor Force (in %) in 1993 in Lower middle income to that in North America?
Your answer should be very brief. 0.8. What is the ratio of the Total Labor Force (in %) in 1991 in Middle East & North Africa (all income levels) to that in Middle East & North Africa (developing only)?
Offer a very short reply. 0.99. What is the ratio of the Total Labor Force (in %) in 1993 in Middle East & North Africa (all income levels) to that in Middle East & North Africa (developing only)?
Offer a terse response. 0.99. What is the ratio of the Total Labor Force (in %) of 1990 in Middle East & North Africa (all income levels) to that in Middle income?
Keep it short and to the point. 0.61. What is the ratio of the Total Labor Force (in %) of 1991 in Middle East & North Africa (all income levels) to that in Middle income?
Give a very brief answer. 0.6. What is the ratio of the Total Labor Force (in %) of 1992 in Middle East & North Africa (all income levels) to that in Middle income?
Keep it short and to the point. 0.61. What is the ratio of the Total Labor Force (in %) of 1993 in Middle East & North Africa (all income levels) to that in Middle income?
Provide a short and direct response. 0.61. What is the ratio of the Total Labor Force (in %) in 1990 in Middle East & North Africa (all income levels) to that in North America?
Give a very brief answer. 0.56. What is the ratio of the Total Labor Force (in %) in 1991 in Middle East & North Africa (all income levels) to that in North America?
Ensure brevity in your answer.  0.57. What is the ratio of the Total Labor Force (in %) of 1992 in Middle East & North Africa (all income levels) to that in North America?
Your answer should be very brief. 0.57. What is the ratio of the Total Labor Force (in %) of 1993 in Middle East & North Africa (all income levels) to that in North America?
Your answer should be very brief. 0.57. What is the ratio of the Total Labor Force (in %) in 1990 in Middle East & North Africa (developing only) to that in Middle income?
Ensure brevity in your answer.  0.61. What is the ratio of the Total Labor Force (in %) of 1991 in Middle East & North Africa (developing only) to that in Middle income?
Offer a very short reply. 0.6. What is the ratio of the Total Labor Force (in %) of 1992 in Middle East & North Africa (developing only) to that in Middle income?
Provide a short and direct response. 0.61. What is the ratio of the Total Labor Force (in %) in 1993 in Middle East & North Africa (developing only) to that in Middle income?
Your answer should be very brief. 0.62. What is the ratio of the Total Labor Force (in %) of 1990 in Middle East & North Africa (developing only) to that in North America?
Offer a very short reply. 0.57. What is the ratio of the Total Labor Force (in %) of 1991 in Middle East & North Africa (developing only) to that in North America?
Your response must be concise. 0.57. What is the ratio of the Total Labor Force (in %) in 1992 in Middle East & North Africa (developing only) to that in North America?
Your answer should be compact. 0.58. What is the ratio of the Total Labor Force (in %) of 1993 in Middle East & North Africa (developing only) to that in North America?
Ensure brevity in your answer.  0.58. What is the ratio of the Total Labor Force (in %) of 1990 in Middle income to that in North America?
Offer a very short reply. 0.93. What is the ratio of the Total Labor Force (in %) of 1991 in Middle income to that in North America?
Your answer should be very brief. 0.95. What is the ratio of the Total Labor Force (in %) in 1992 in Middle income to that in North America?
Your answer should be very brief. 0.95. What is the ratio of the Total Labor Force (in %) of 1993 in Middle income to that in North America?
Your response must be concise. 0.94. What is the difference between the highest and the second highest Total Labor Force (in %) of 1990?
Your response must be concise. 1.17. What is the difference between the highest and the second highest Total Labor Force (in %) of 1991?
Your answer should be very brief. 3. What is the difference between the highest and the second highest Total Labor Force (in %) in 1992?
Keep it short and to the point. 3.37. What is the difference between the highest and the second highest Total Labor Force (in %) of 1993?
Provide a succinct answer. 3.42. What is the difference between the highest and the lowest Total Labor Force (in %) in 1990?
Offer a terse response. 29.55. What is the difference between the highest and the lowest Total Labor Force (in %) in 1991?
Keep it short and to the point. 30.17. What is the difference between the highest and the lowest Total Labor Force (in %) of 1992?
Your answer should be very brief. 30.02. What is the difference between the highest and the lowest Total Labor Force (in %) of 1993?
Offer a terse response. 30.02. 